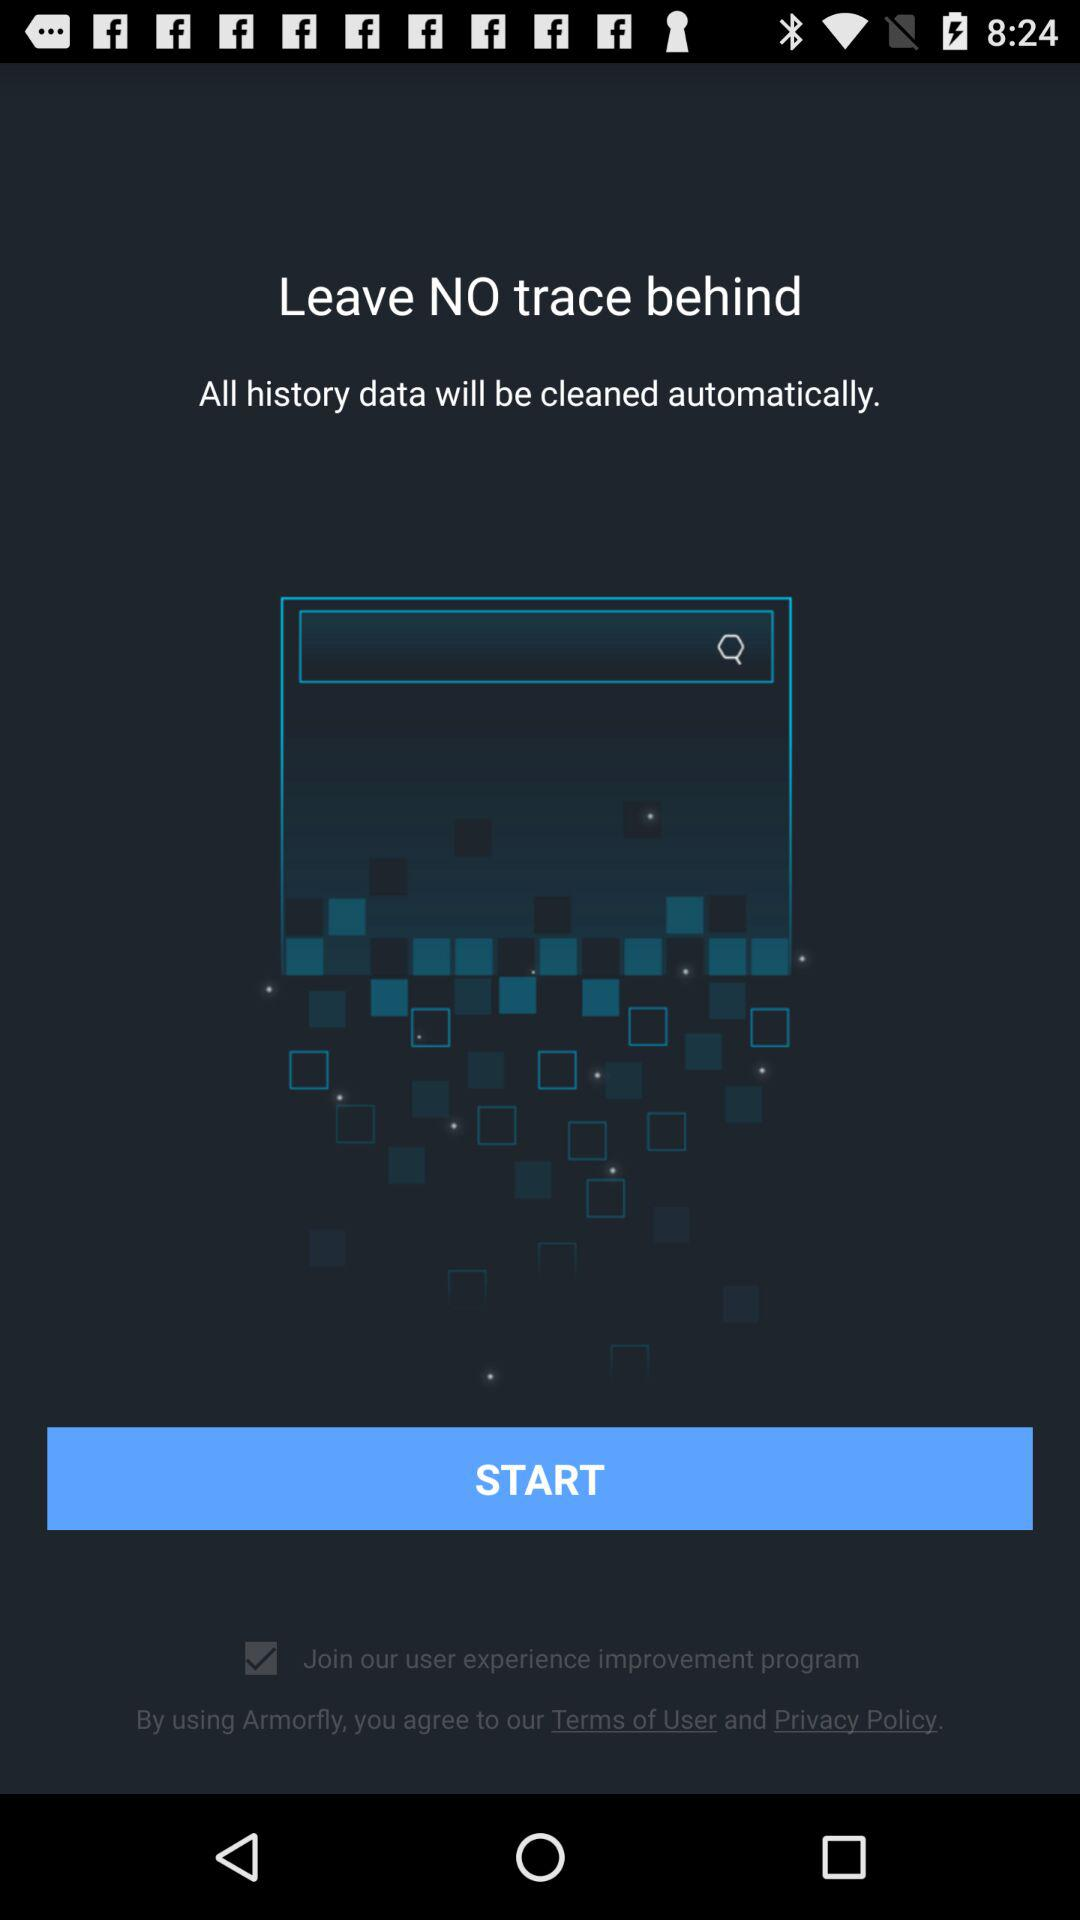What is the status of "Join our user experience improvement program"? The status is "on". 